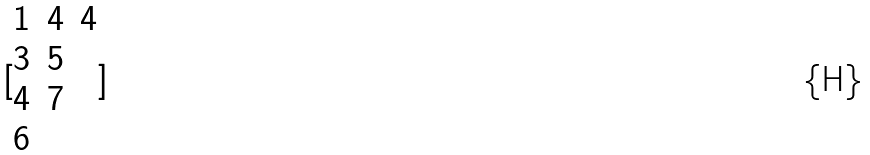<formula> <loc_0><loc_0><loc_500><loc_500>[ \begin{matrix} 1 & 4 & 4 \\ 3 & 5 \\ 4 & 7 \\ 6 \end{matrix} ]</formula> 